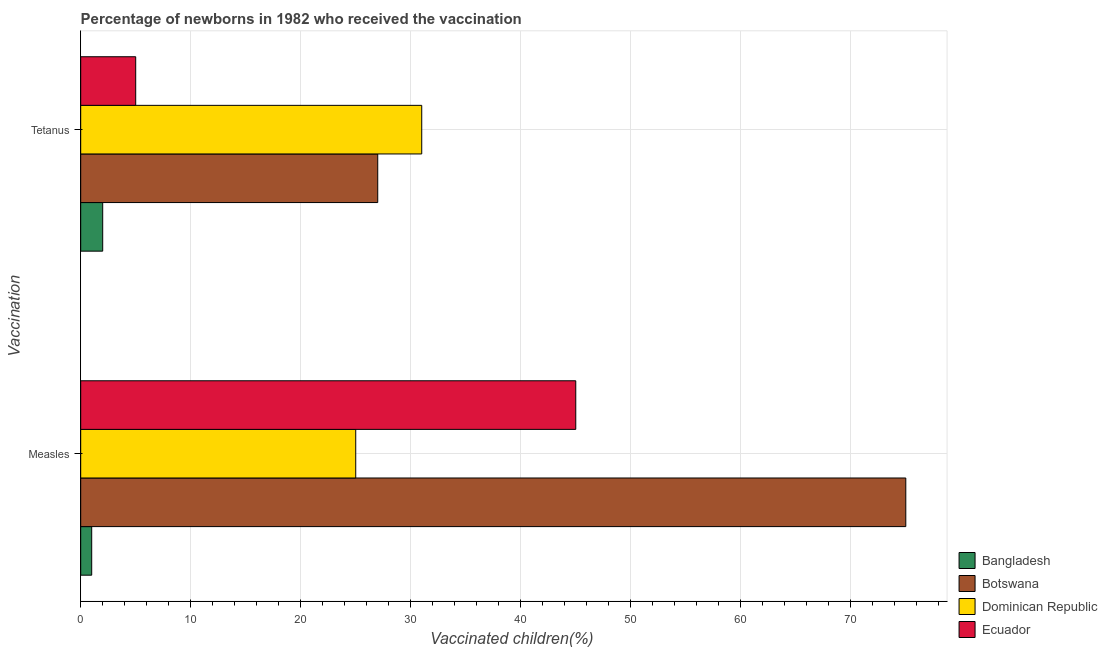Are the number of bars on each tick of the Y-axis equal?
Give a very brief answer. Yes. How many bars are there on the 1st tick from the bottom?
Your answer should be very brief. 4. What is the label of the 2nd group of bars from the top?
Your answer should be compact. Measles. What is the percentage of newborns who received vaccination for tetanus in Botswana?
Your response must be concise. 27. Across all countries, what is the maximum percentage of newborns who received vaccination for tetanus?
Ensure brevity in your answer.  31. Across all countries, what is the minimum percentage of newborns who received vaccination for measles?
Keep it short and to the point. 1. In which country was the percentage of newborns who received vaccination for tetanus maximum?
Offer a terse response. Dominican Republic. In which country was the percentage of newborns who received vaccination for tetanus minimum?
Offer a terse response. Bangladesh. What is the total percentage of newborns who received vaccination for measles in the graph?
Keep it short and to the point. 146. What is the difference between the percentage of newborns who received vaccination for measles in Ecuador and that in Botswana?
Provide a short and direct response. -30. What is the difference between the percentage of newborns who received vaccination for tetanus in Bangladesh and the percentage of newborns who received vaccination for measles in Botswana?
Provide a succinct answer. -73. What is the average percentage of newborns who received vaccination for tetanus per country?
Make the answer very short. 16.25. What is the difference between the percentage of newborns who received vaccination for measles and percentage of newborns who received vaccination for tetanus in Ecuador?
Make the answer very short. 40. In how many countries, is the percentage of newborns who received vaccination for tetanus greater than 42 %?
Your answer should be compact. 0. Is the percentage of newborns who received vaccination for measles in Botswana less than that in Ecuador?
Offer a terse response. No. What does the 3rd bar from the top in Tetanus represents?
Your answer should be very brief. Botswana. What does the 2nd bar from the bottom in Tetanus represents?
Give a very brief answer. Botswana. How many bars are there?
Your answer should be compact. 8. Are all the bars in the graph horizontal?
Ensure brevity in your answer.  Yes. Are the values on the major ticks of X-axis written in scientific E-notation?
Offer a very short reply. No. Does the graph contain any zero values?
Give a very brief answer. No. Does the graph contain grids?
Give a very brief answer. Yes. What is the title of the graph?
Keep it short and to the point. Percentage of newborns in 1982 who received the vaccination. Does "Northern Mariana Islands" appear as one of the legend labels in the graph?
Offer a terse response. No. What is the label or title of the X-axis?
Offer a very short reply. Vaccinated children(%)
. What is the label or title of the Y-axis?
Your answer should be very brief. Vaccination. What is the Vaccinated children(%)
 of Dominican Republic in Measles?
Your response must be concise. 25. What is the Vaccinated children(%)
 of Ecuador in Measles?
Your answer should be very brief. 45. What is the Vaccinated children(%)
 of Bangladesh in Tetanus?
Your answer should be compact. 2. What is the Vaccinated children(%)
 in Dominican Republic in Tetanus?
Provide a short and direct response. 31. What is the Vaccinated children(%)
 in Ecuador in Tetanus?
Give a very brief answer. 5. Across all Vaccination, what is the maximum Vaccinated children(%)
 of Dominican Republic?
Provide a succinct answer. 31. Across all Vaccination, what is the maximum Vaccinated children(%)
 in Ecuador?
Ensure brevity in your answer.  45. Across all Vaccination, what is the minimum Vaccinated children(%)
 in Bangladesh?
Keep it short and to the point. 1. Across all Vaccination, what is the minimum Vaccinated children(%)
 of Dominican Republic?
Your answer should be compact. 25. What is the total Vaccinated children(%)
 of Bangladesh in the graph?
Your response must be concise. 3. What is the total Vaccinated children(%)
 in Botswana in the graph?
Keep it short and to the point. 102. What is the total Vaccinated children(%)
 in Dominican Republic in the graph?
Your answer should be compact. 56. What is the difference between the Vaccinated children(%)
 of Botswana in Measles and that in Tetanus?
Your response must be concise. 48. What is the difference between the Vaccinated children(%)
 in Bangladesh in Measles and the Vaccinated children(%)
 in Botswana in Tetanus?
Your response must be concise. -26. What is the difference between the Vaccinated children(%)
 in Dominican Republic in Measles and the Vaccinated children(%)
 in Ecuador in Tetanus?
Provide a short and direct response. 20. What is the average Vaccinated children(%)
 of Bangladesh per Vaccination?
Offer a very short reply. 1.5. What is the average Vaccinated children(%)
 in Ecuador per Vaccination?
Provide a short and direct response. 25. What is the difference between the Vaccinated children(%)
 in Bangladesh and Vaccinated children(%)
 in Botswana in Measles?
Give a very brief answer. -74. What is the difference between the Vaccinated children(%)
 in Bangladesh and Vaccinated children(%)
 in Ecuador in Measles?
Your response must be concise. -44. What is the difference between the Vaccinated children(%)
 in Botswana and Vaccinated children(%)
 in Dominican Republic in Measles?
Give a very brief answer. 50. What is the difference between the Vaccinated children(%)
 of Dominican Republic and Vaccinated children(%)
 of Ecuador in Measles?
Make the answer very short. -20. What is the difference between the Vaccinated children(%)
 in Bangladesh and Vaccinated children(%)
 in Ecuador in Tetanus?
Keep it short and to the point. -3. What is the difference between the Vaccinated children(%)
 in Botswana and Vaccinated children(%)
 in Dominican Republic in Tetanus?
Provide a short and direct response. -4. What is the difference between the Vaccinated children(%)
 in Botswana and Vaccinated children(%)
 in Ecuador in Tetanus?
Provide a succinct answer. 22. What is the ratio of the Vaccinated children(%)
 in Botswana in Measles to that in Tetanus?
Give a very brief answer. 2.78. What is the ratio of the Vaccinated children(%)
 in Dominican Republic in Measles to that in Tetanus?
Offer a very short reply. 0.81. What is the difference between the highest and the second highest Vaccinated children(%)
 in Bangladesh?
Make the answer very short. 1. What is the difference between the highest and the lowest Vaccinated children(%)
 of Bangladesh?
Your response must be concise. 1. What is the difference between the highest and the lowest Vaccinated children(%)
 in Ecuador?
Offer a terse response. 40. 